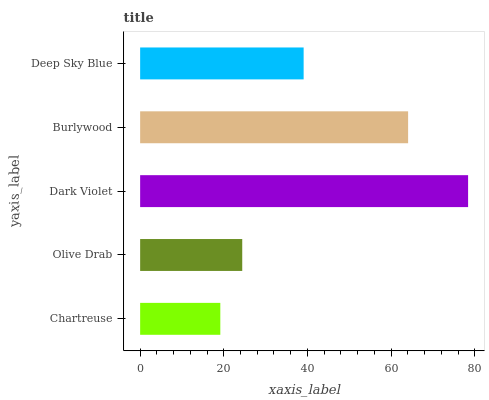Is Chartreuse the minimum?
Answer yes or no. Yes. Is Dark Violet the maximum?
Answer yes or no. Yes. Is Olive Drab the minimum?
Answer yes or no. No. Is Olive Drab the maximum?
Answer yes or no. No. Is Olive Drab greater than Chartreuse?
Answer yes or no. Yes. Is Chartreuse less than Olive Drab?
Answer yes or no. Yes. Is Chartreuse greater than Olive Drab?
Answer yes or no. No. Is Olive Drab less than Chartreuse?
Answer yes or no. No. Is Deep Sky Blue the high median?
Answer yes or no. Yes. Is Deep Sky Blue the low median?
Answer yes or no. Yes. Is Dark Violet the high median?
Answer yes or no. No. Is Olive Drab the low median?
Answer yes or no. No. 